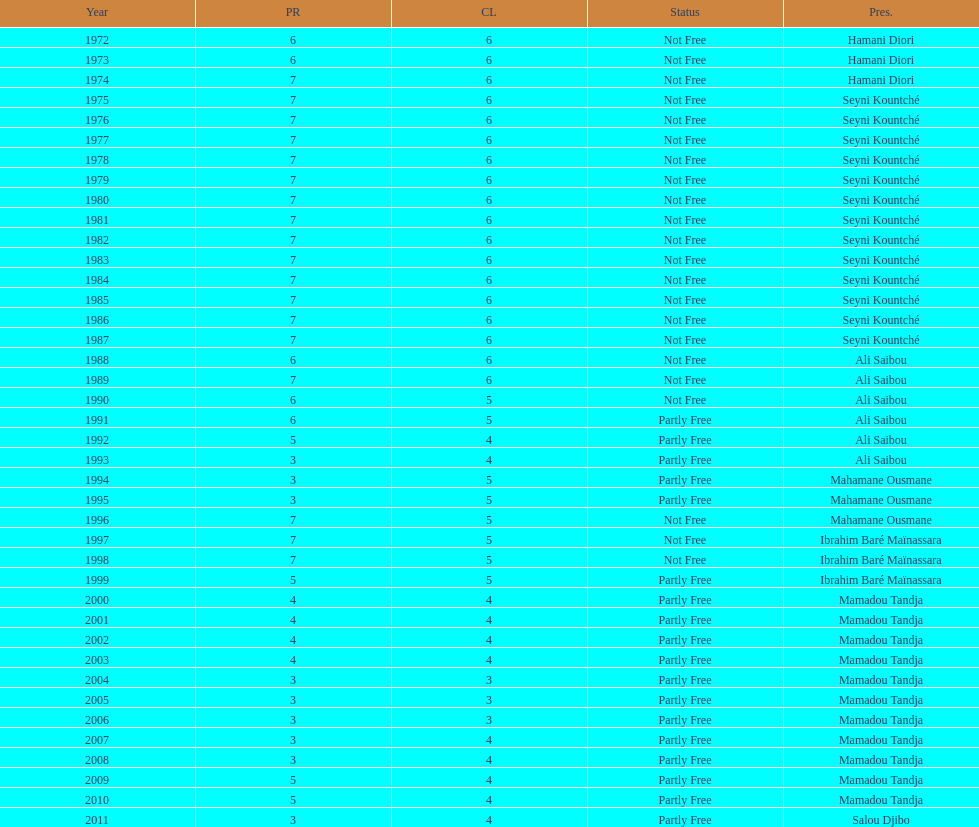In how many cases were the political rights mentioned as seven? 18. 